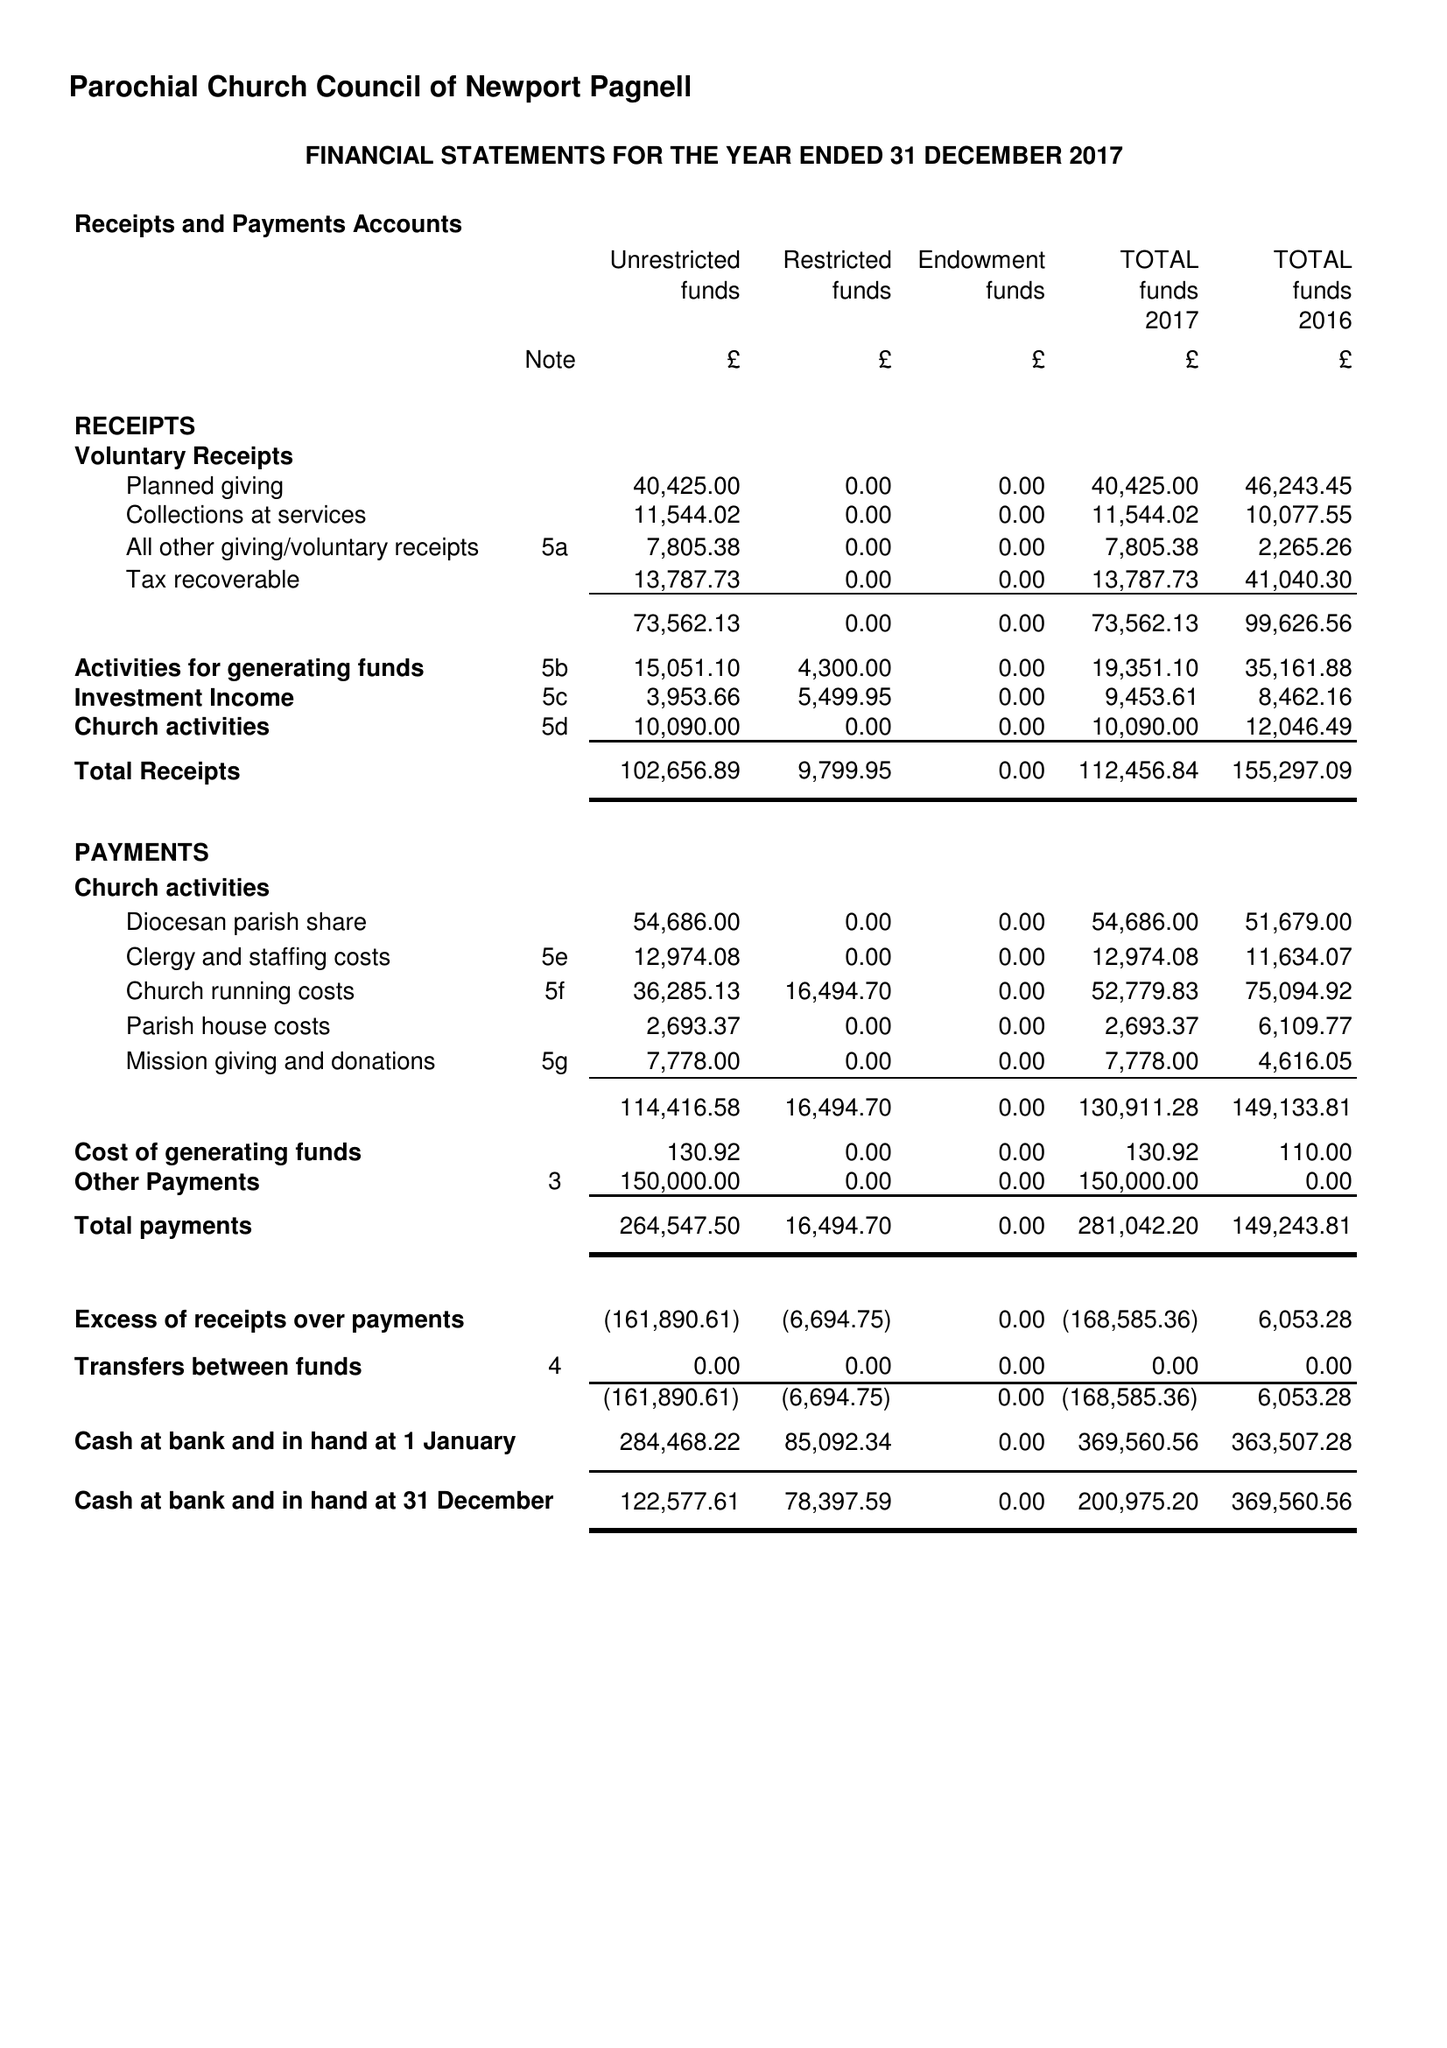What is the value for the charity_number?
Answer the question using a single word or phrase. 1153668 